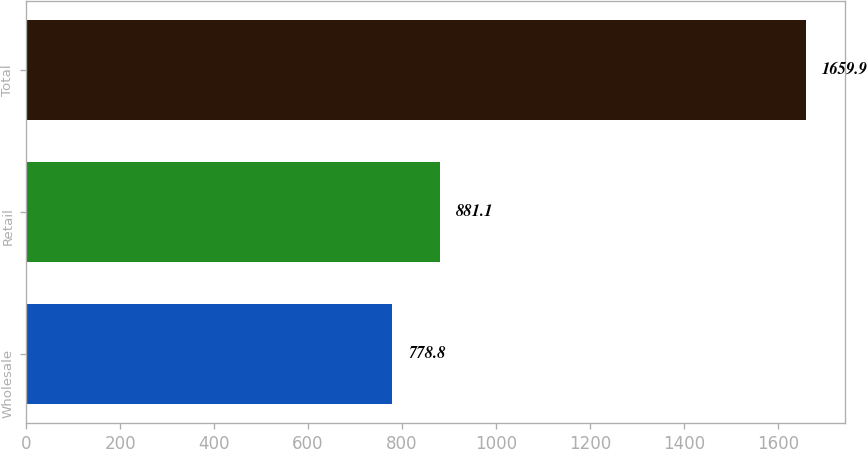Convert chart. <chart><loc_0><loc_0><loc_500><loc_500><bar_chart><fcel>Wholesale<fcel>Retail<fcel>Total<nl><fcel>778.8<fcel>881.1<fcel>1659.9<nl></chart> 